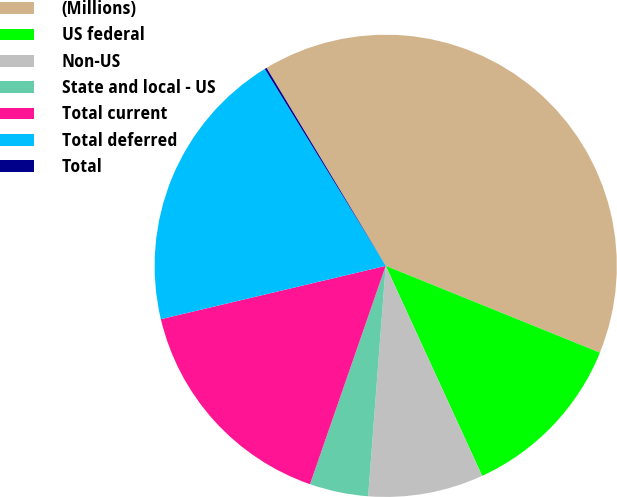<chart> <loc_0><loc_0><loc_500><loc_500><pie_chart><fcel>(Millions)<fcel>US federal<fcel>Non-US<fcel>State and local - US<fcel>Total current<fcel>Total deferred<fcel>Total<nl><fcel>39.75%<fcel>12.02%<fcel>8.06%<fcel>4.1%<fcel>15.98%<fcel>19.94%<fcel>0.14%<nl></chart> 